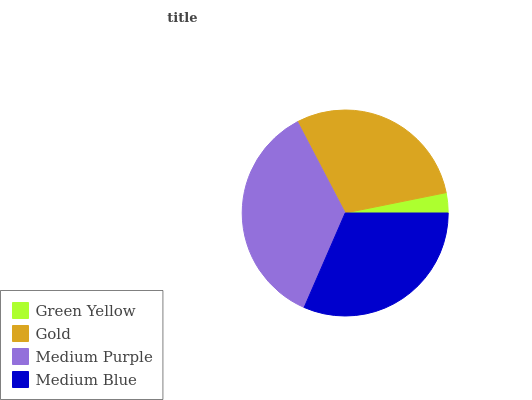Is Green Yellow the minimum?
Answer yes or no. Yes. Is Medium Purple the maximum?
Answer yes or no. Yes. Is Gold the minimum?
Answer yes or no. No. Is Gold the maximum?
Answer yes or no. No. Is Gold greater than Green Yellow?
Answer yes or no. Yes. Is Green Yellow less than Gold?
Answer yes or no. Yes. Is Green Yellow greater than Gold?
Answer yes or no. No. Is Gold less than Green Yellow?
Answer yes or no. No. Is Medium Blue the high median?
Answer yes or no. Yes. Is Gold the low median?
Answer yes or no. Yes. Is Green Yellow the high median?
Answer yes or no. No. Is Medium Purple the low median?
Answer yes or no. No. 